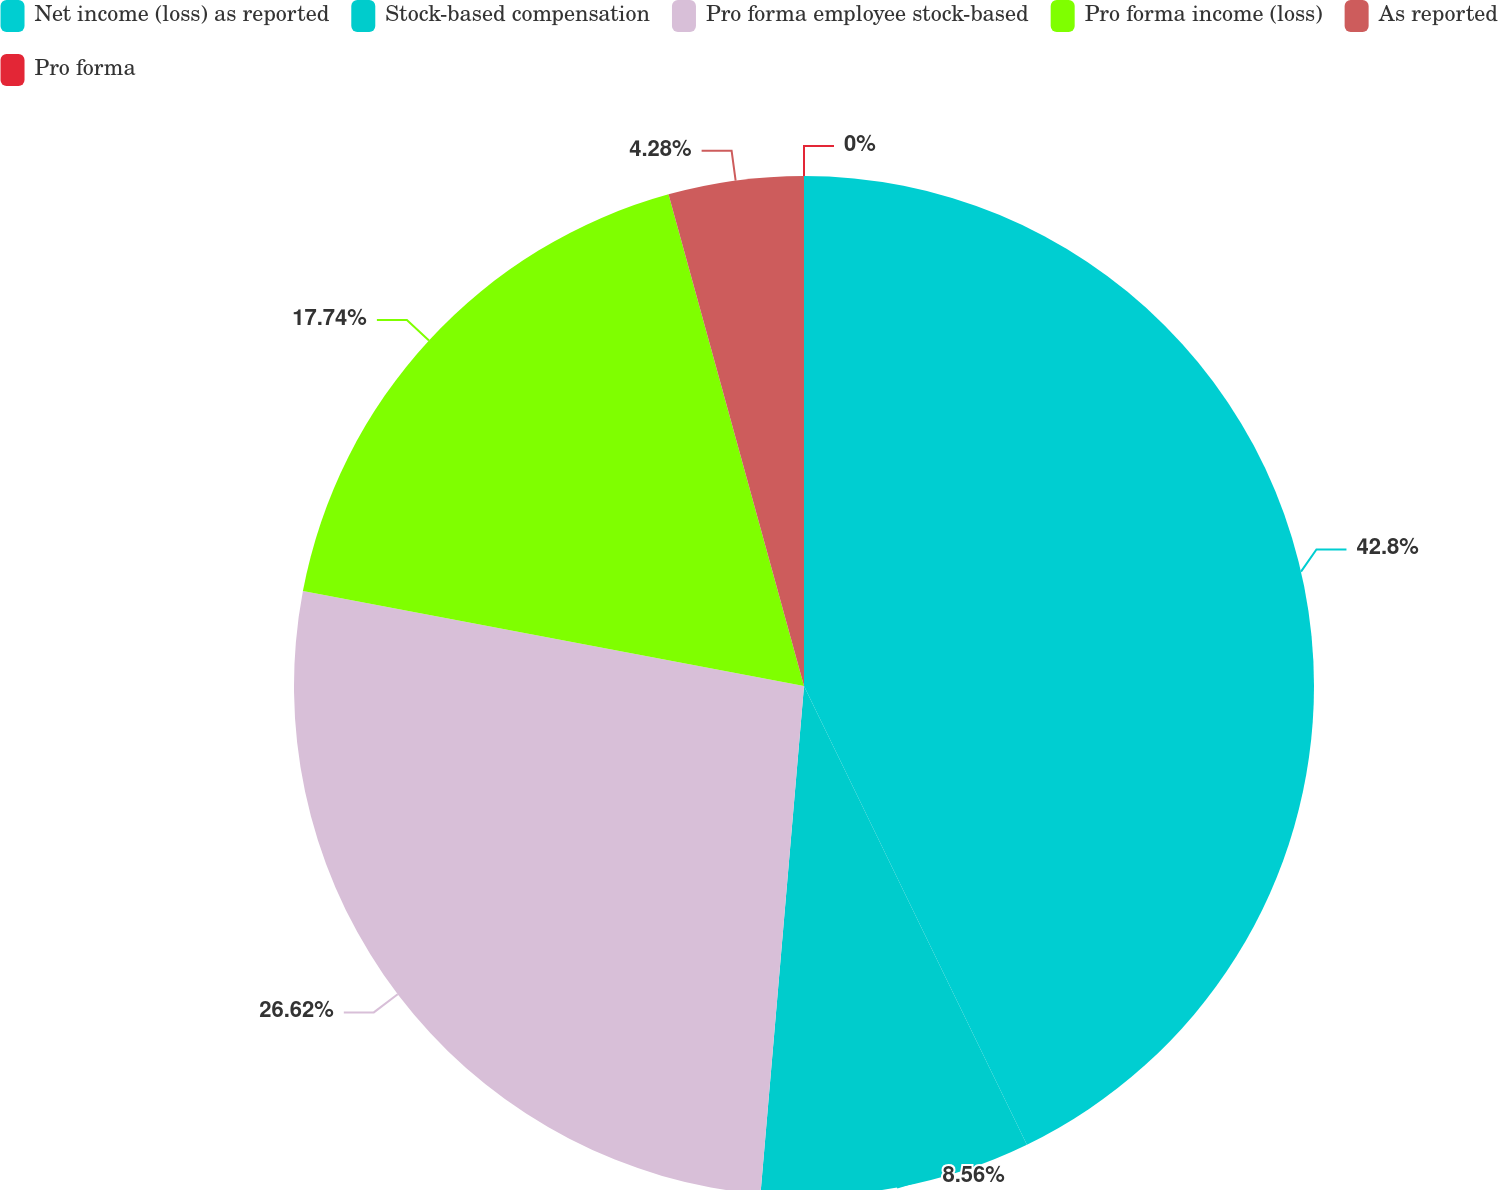Convert chart to OTSL. <chart><loc_0><loc_0><loc_500><loc_500><pie_chart><fcel>Net income (loss) as reported<fcel>Stock-based compensation<fcel>Pro forma employee stock-based<fcel>Pro forma income (loss)<fcel>As reported<fcel>Pro forma<nl><fcel>42.8%<fcel>8.56%<fcel>26.62%<fcel>17.74%<fcel>4.28%<fcel>0.0%<nl></chart> 